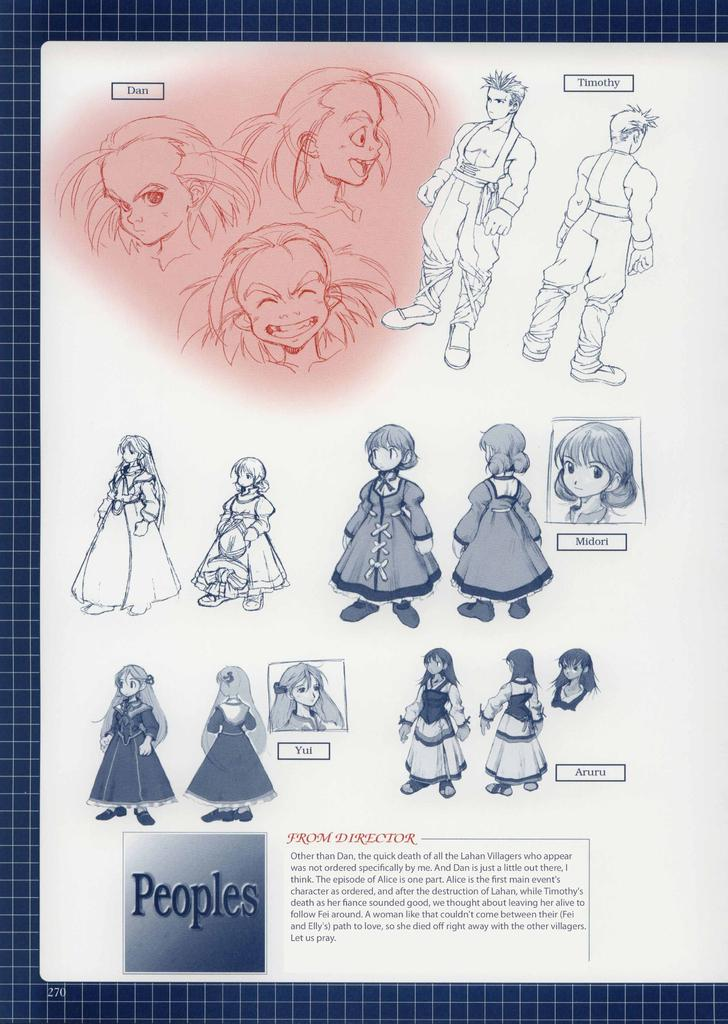What is the color of the main object in the image? The main object in the image is white. What is depicted on the white object? The white object has a depiction of people. Are there any words or letters on the white object? Yes, there is writing on the white object. How does the muscle affect the ear in the image? There is no muscle or ear present in the image; it only features a white object with a depiction of people and writing. 